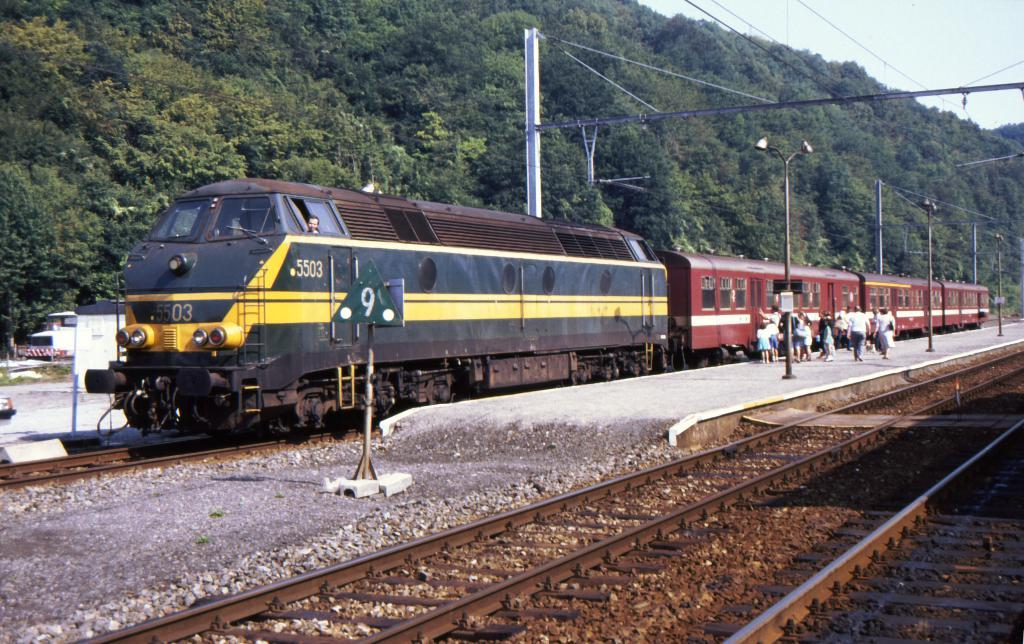<image>
Give a short and clear explanation of the subsequent image. A passenger train stopped outside at the number 9 sign. 